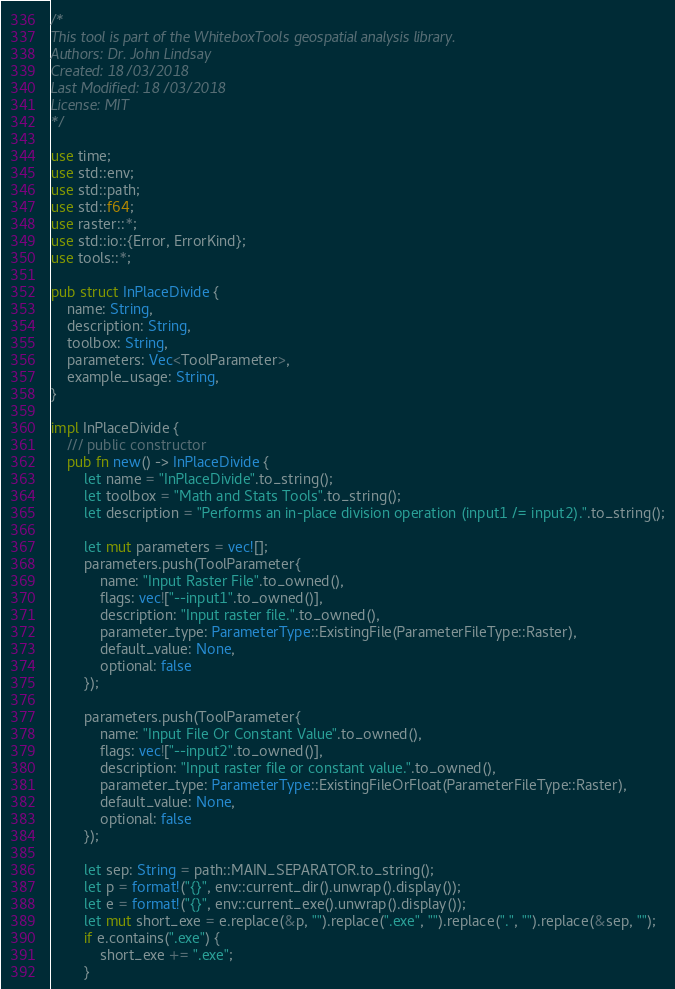<code> <loc_0><loc_0><loc_500><loc_500><_Rust_>/* 
This tool is part of the WhiteboxTools geospatial analysis library.
Authors: Dr. John Lindsay
Created: 18/03/2018
Last Modified: 18/03/2018
License: MIT
*/

use time;
use std::env;
use std::path;
use std::f64;
use raster::*;
use std::io::{Error, ErrorKind};
use tools::*;

pub struct InPlaceDivide {
    name: String,
    description: String,
    toolbox: String,
    parameters: Vec<ToolParameter>,
    example_usage: String,
}

impl InPlaceDivide {
    /// public constructor
    pub fn new() -> InPlaceDivide { 
        let name = "InPlaceDivide".to_string();
        let toolbox = "Math and Stats Tools".to_string();
        let description = "Performs an in-place division operation (input1 /= input2).".to_string();
        
        let mut parameters = vec![];
        parameters.push(ToolParameter{
            name: "Input Raster File".to_owned(), 
            flags: vec!["--input1".to_owned()], 
            description: "Input raster file.".to_owned(),
            parameter_type: ParameterType::ExistingFile(ParameterFileType::Raster),
            default_value: None,
            optional: false
        });

        parameters.push(ToolParameter{
            name: "Input File Or Constant Value".to_owned(), 
            flags: vec!["--input2".to_owned()], 
            description: "Input raster file or constant value.".to_owned(),
            parameter_type: ParameterType::ExistingFileOrFloat(ParameterFileType::Raster),
            default_value: None,
            optional: false
        });
         
        let sep: String = path::MAIN_SEPARATOR.to_string();
        let p = format!("{}", env::current_dir().unwrap().display());
        let e = format!("{}", env::current_exe().unwrap().display());
        let mut short_exe = e.replace(&p, "").replace(".exe", "").replace(".", "").replace(&sep, "");
        if e.contains(".exe") {
            short_exe += ".exe";
        }</code> 